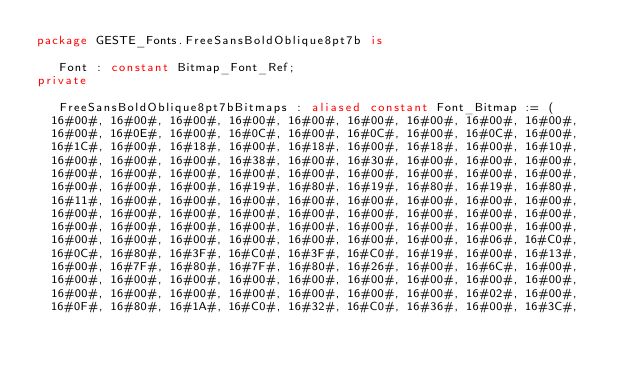Convert code to text. <code><loc_0><loc_0><loc_500><loc_500><_Ada_>package GESTE_Fonts.FreeSansBoldOblique8pt7b is

   Font : constant Bitmap_Font_Ref;
private

   FreeSansBoldOblique8pt7bBitmaps : aliased constant Font_Bitmap := (
  16#00#, 16#00#, 16#00#, 16#00#, 16#00#, 16#00#, 16#00#, 16#00#, 16#00#,
  16#00#, 16#0E#, 16#00#, 16#0C#, 16#00#, 16#0C#, 16#00#, 16#0C#, 16#00#,
  16#1C#, 16#00#, 16#18#, 16#00#, 16#18#, 16#00#, 16#18#, 16#00#, 16#10#,
  16#00#, 16#00#, 16#00#, 16#38#, 16#00#, 16#30#, 16#00#, 16#00#, 16#00#,
  16#00#, 16#00#, 16#00#, 16#00#, 16#00#, 16#00#, 16#00#, 16#00#, 16#00#,
  16#00#, 16#00#, 16#00#, 16#19#, 16#80#, 16#19#, 16#80#, 16#19#, 16#80#,
  16#11#, 16#00#, 16#00#, 16#00#, 16#00#, 16#00#, 16#00#, 16#00#, 16#00#,
  16#00#, 16#00#, 16#00#, 16#00#, 16#00#, 16#00#, 16#00#, 16#00#, 16#00#,
  16#00#, 16#00#, 16#00#, 16#00#, 16#00#, 16#00#, 16#00#, 16#00#, 16#00#,
  16#00#, 16#00#, 16#00#, 16#00#, 16#00#, 16#00#, 16#00#, 16#06#, 16#C0#,
  16#0C#, 16#80#, 16#3F#, 16#C0#, 16#3F#, 16#C0#, 16#19#, 16#00#, 16#13#,
  16#00#, 16#7F#, 16#80#, 16#7F#, 16#80#, 16#26#, 16#00#, 16#6C#, 16#00#,
  16#00#, 16#00#, 16#00#, 16#00#, 16#00#, 16#00#, 16#00#, 16#00#, 16#00#,
  16#00#, 16#00#, 16#00#, 16#00#, 16#00#, 16#00#, 16#00#, 16#02#, 16#00#,
  16#0F#, 16#80#, 16#1A#, 16#C0#, 16#32#, 16#C0#, 16#36#, 16#00#, 16#3C#,</code> 